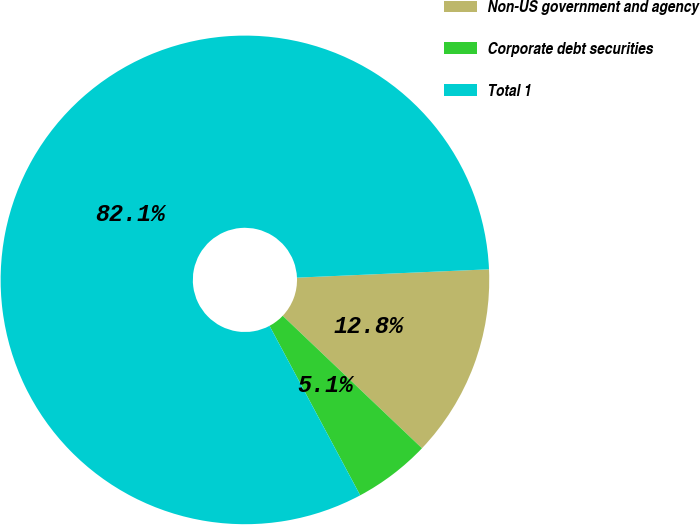Convert chart to OTSL. <chart><loc_0><loc_0><loc_500><loc_500><pie_chart><fcel>Non-US government and agency<fcel>Corporate debt securities<fcel>Total 1<nl><fcel>12.79%<fcel>5.08%<fcel>82.13%<nl></chart> 